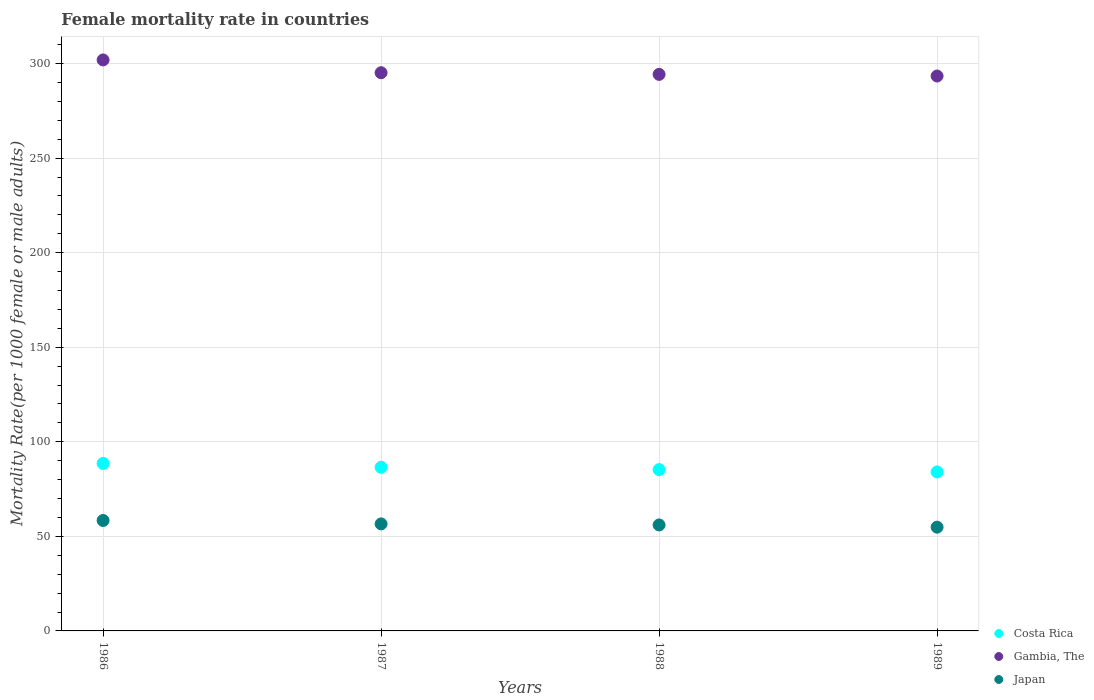What is the female mortality rate in Gambia, The in 1988?
Provide a short and direct response. 294.31. Across all years, what is the maximum female mortality rate in Gambia, The?
Give a very brief answer. 301.94. Across all years, what is the minimum female mortality rate in Japan?
Make the answer very short. 54.87. In which year was the female mortality rate in Costa Rica maximum?
Your answer should be very brief. 1986. In which year was the female mortality rate in Japan minimum?
Offer a terse response. 1989. What is the total female mortality rate in Japan in the graph?
Your answer should be compact. 225.9. What is the difference between the female mortality rate in Japan in 1988 and that in 1989?
Your answer should be very brief. 1.17. What is the difference between the female mortality rate in Costa Rica in 1988 and the female mortality rate in Japan in 1987?
Your answer should be compact. 28.69. What is the average female mortality rate in Gambia, The per year?
Provide a succinct answer. 296.22. In the year 1989, what is the difference between the female mortality rate in Costa Rica and female mortality rate in Gambia, The?
Offer a very short reply. -209.36. What is the ratio of the female mortality rate in Gambia, The in 1986 to that in 1987?
Provide a succinct answer. 1.02. Is the female mortality rate in Gambia, The in 1987 less than that in 1988?
Give a very brief answer. No. What is the difference between the highest and the second highest female mortality rate in Gambia, The?
Your response must be concise. 6.76. What is the difference between the highest and the lowest female mortality rate in Japan?
Provide a succinct answer. 3.53. Does the female mortality rate in Costa Rica monotonically increase over the years?
Provide a short and direct response. No. Does the graph contain grids?
Your answer should be compact. Yes. How many legend labels are there?
Offer a terse response. 3. How are the legend labels stacked?
Offer a very short reply. Vertical. What is the title of the graph?
Your answer should be compact. Female mortality rate in countries. What is the label or title of the X-axis?
Provide a short and direct response. Years. What is the label or title of the Y-axis?
Provide a short and direct response. Mortality Rate(per 1000 female or male adults). What is the Mortality Rate(per 1000 female or male adults) in Costa Rica in 1986?
Provide a succinct answer. 88.56. What is the Mortality Rate(per 1000 female or male adults) in Gambia, The in 1986?
Your answer should be compact. 301.94. What is the Mortality Rate(per 1000 female or male adults) in Japan in 1986?
Ensure brevity in your answer.  58.4. What is the Mortality Rate(per 1000 female or male adults) in Costa Rica in 1987?
Offer a very short reply. 86.5. What is the Mortality Rate(per 1000 female or male adults) in Gambia, The in 1987?
Provide a succinct answer. 295.18. What is the Mortality Rate(per 1000 female or male adults) of Japan in 1987?
Offer a terse response. 56.6. What is the Mortality Rate(per 1000 female or male adults) of Costa Rica in 1988?
Provide a short and direct response. 85.29. What is the Mortality Rate(per 1000 female or male adults) of Gambia, The in 1988?
Ensure brevity in your answer.  294.31. What is the Mortality Rate(per 1000 female or male adults) of Japan in 1988?
Your answer should be very brief. 56.04. What is the Mortality Rate(per 1000 female or male adults) in Costa Rica in 1989?
Offer a terse response. 84.08. What is the Mortality Rate(per 1000 female or male adults) of Gambia, The in 1989?
Offer a very short reply. 293.44. What is the Mortality Rate(per 1000 female or male adults) of Japan in 1989?
Give a very brief answer. 54.87. Across all years, what is the maximum Mortality Rate(per 1000 female or male adults) in Costa Rica?
Ensure brevity in your answer.  88.56. Across all years, what is the maximum Mortality Rate(per 1000 female or male adults) in Gambia, The?
Ensure brevity in your answer.  301.94. Across all years, what is the maximum Mortality Rate(per 1000 female or male adults) in Japan?
Make the answer very short. 58.4. Across all years, what is the minimum Mortality Rate(per 1000 female or male adults) of Costa Rica?
Your response must be concise. 84.08. Across all years, what is the minimum Mortality Rate(per 1000 female or male adults) in Gambia, The?
Your answer should be very brief. 293.44. Across all years, what is the minimum Mortality Rate(per 1000 female or male adults) of Japan?
Your answer should be compact. 54.87. What is the total Mortality Rate(per 1000 female or male adults) in Costa Rica in the graph?
Offer a terse response. 344.44. What is the total Mortality Rate(per 1000 female or male adults) of Gambia, The in the graph?
Ensure brevity in your answer.  1184.87. What is the total Mortality Rate(per 1000 female or male adults) in Japan in the graph?
Your answer should be very brief. 225.9. What is the difference between the Mortality Rate(per 1000 female or male adults) in Costa Rica in 1986 and that in 1987?
Keep it short and to the point. 2.06. What is the difference between the Mortality Rate(per 1000 female or male adults) of Gambia, The in 1986 and that in 1987?
Keep it short and to the point. 6.76. What is the difference between the Mortality Rate(per 1000 female or male adults) of Costa Rica in 1986 and that in 1988?
Provide a succinct answer. 3.27. What is the difference between the Mortality Rate(per 1000 female or male adults) in Gambia, The in 1986 and that in 1988?
Provide a short and direct response. 7.64. What is the difference between the Mortality Rate(per 1000 female or male adults) in Japan in 1986 and that in 1988?
Provide a short and direct response. 2.36. What is the difference between the Mortality Rate(per 1000 female or male adults) of Costa Rica in 1986 and that in 1989?
Your answer should be very brief. 4.49. What is the difference between the Mortality Rate(per 1000 female or male adults) in Gambia, The in 1986 and that in 1989?
Keep it short and to the point. 8.51. What is the difference between the Mortality Rate(per 1000 female or male adults) of Japan in 1986 and that in 1989?
Make the answer very short. 3.53. What is the difference between the Mortality Rate(per 1000 female or male adults) in Costa Rica in 1987 and that in 1988?
Give a very brief answer. 1.21. What is the difference between the Mortality Rate(per 1000 female or male adults) of Gambia, The in 1987 and that in 1988?
Provide a succinct answer. 0.87. What is the difference between the Mortality Rate(per 1000 female or male adults) in Japan in 1987 and that in 1988?
Provide a succinct answer. 0.56. What is the difference between the Mortality Rate(per 1000 female or male adults) in Costa Rica in 1987 and that in 1989?
Keep it short and to the point. 2.42. What is the difference between the Mortality Rate(per 1000 female or male adults) in Gambia, The in 1987 and that in 1989?
Give a very brief answer. 1.74. What is the difference between the Mortality Rate(per 1000 female or male adults) of Japan in 1987 and that in 1989?
Give a very brief answer. 1.73. What is the difference between the Mortality Rate(per 1000 female or male adults) of Costa Rica in 1988 and that in 1989?
Provide a short and direct response. 1.21. What is the difference between the Mortality Rate(per 1000 female or male adults) in Gambia, The in 1988 and that in 1989?
Provide a short and direct response. 0.87. What is the difference between the Mortality Rate(per 1000 female or male adults) of Japan in 1988 and that in 1989?
Offer a very short reply. 1.17. What is the difference between the Mortality Rate(per 1000 female or male adults) in Costa Rica in 1986 and the Mortality Rate(per 1000 female or male adults) in Gambia, The in 1987?
Your response must be concise. -206.61. What is the difference between the Mortality Rate(per 1000 female or male adults) of Costa Rica in 1986 and the Mortality Rate(per 1000 female or male adults) of Japan in 1987?
Make the answer very short. 31.97. What is the difference between the Mortality Rate(per 1000 female or male adults) of Gambia, The in 1986 and the Mortality Rate(per 1000 female or male adults) of Japan in 1987?
Provide a succinct answer. 245.35. What is the difference between the Mortality Rate(per 1000 female or male adults) in Costa Rica in 1986 and the Mortality Rate(per 1000 female or male adults) in Gambia, The in 1988?
Keep it short and to the point. -205.74. What is the difference between the Mortality Rate(per 1000 female or male adults) in Costa Rica in 1986 and the Mortality Rate(per 1000 female or male adults) in Japan in 1988?
Offer a very short reply. 32.53. What is the difference between the Mortality Rate(per 1000 female or male adults) in Gambia, The in 1986 and the Mortality Rate(per 1000 female or male adults) in Japan in 1988?
Offer a very short reply. 245.9. What is the difference between the Mortality Rate(per 1000 female or male adults) of Costa Rica in 1986 and the Mortality Rate(per 1000 female or male adults) of Gambia, The in 1989?
Your response must be concise. -204.87. What is the difference between the Mortality Rate(per 1000 female or male adults) in Costa Rica in 1986 and the Mortality Rate(per 1000 female or male adults) in Japan in 1989?
Offer a very short reply. 33.7. What is the difference between the Mortality Rate(per 1000 female or male adults) in Gambia, The in 1986 and the Mortality Rate(per 1000 female or male adults) in Japan in 1989?
Your response must be concise. 247.07. What is the difference between the Mortality Rate(per 1000 female or male adults) of Costa Rica in 1987 and the Mortality Rate(per 1000 female or male adults) of Gambia, The in 1988?
Keep it short and to the point. -207.8. What is the difference between the Mortality Rate(per 1000 female or male adults) in Costa Rica in 1987 and the Mortality Rate(per 1000 female or male adults) in Japan in 1988?
Provide a succinct answer. 30.46. What is the difference between the Mortality Rate(per 1000 female or male adults) of Gambia, The in 1987 and the Mortality Rate(per 1000 female or male adults) of Japan in 1988?
Make the answer very short. 239.14. What is the difference between the Mortality Rate(per 1000 female or male adults) in Costa Rica in 1987 and the Mortality Rate(per 1000 female or male adults) in Gambia, The in 1989?
Make the answer very short. -206.93. What is the difference between the Mortality Rate(per 1000 female or male adults) of Costa Rica in 1987 and the Mortality Rate(per 1000 female or male adults) of Japan in 1989?
Your answer should be very brief. 31.64. What is the difference between the Mortality Rate(per 1000 female or male adults) of Gambia, The in 1987 and the Mortality Rate(per 1000 female or male adults) of Japan in 1989?
Offer a terse response. 240.31. What is the difference between the Mortality Rate(per 1000 female or male adults) of Costa Rica in 1988 and the Mortality Rate(per 1000 female or male adults) of Gambia, The in 1989?
Provide a short and direct response. -208.15. What is the difference between the Mortality Rate(per 1000 female or male adults) in Costa Rica in 1988 and the Mortality Rate(per 1000 female or male adults) in Japan in 1989?
Offer a very short reply. 30.42. What is the difference between the Mortality Rate(per 1000 female or male adults) in Gambia, The in 1988 and the Mortality Rate(per 1000 female or male adults) in Japan in 1989?
Your answer should be very brief. 239.44. What is the average Mortality Rate(per 1000 female or male adults) of Costa Rica per year?
Offer a very short reply. 86.11. What is the average Mortality Rate(per 1000 female or male adults) in Gambia, The per year?
Offer a terse response. 296.22. What is the average Mortality Rate(per 1000 female or male adults) of Japan per year?
Give a very brief answer. 56.48. In the year 1986, what is the difference between the Mortality Rate(per 1000 female or male adults) of Costa Rica and Mortality Rate(per 1000 female or male adults) of Gambia, The?
Offer a very short reply. -213.38. In the year 1986, what is the difference between the Mortality Rate(per 1000 female or male adults) of Costa Rica and Mortality Rate(per 1000 female or male adults) of Japan?
Offer a terse response. 30.17. In the year 1986, what is the difference between the Mortality Rate(per 1000 female or male adults) in Gambia, The and Mortality Rate(per 1000 female or male adults) in Japan?
Provide a succinct answer. 243.55. In the year 1987, what is the difference between the Mortality Rate(per 1000 female or male adults) in Costa Rica and Mortality Rate(per 1000 female or male adults) in Gambia, The?
Keep it short and to the point. -208.68. In the year 1987, what is the difference between the Mortality Rate(per 1000 female or male adults) in Costa Rica and Mortality Rate(per 1000 female or male adults) in Japan?
Provide a succinct answer. 29.91. In the year 1987, what is the difference between the Mortality Rate(per 1000 female or male adults) in Gambia, The and Mortality Rate(per 1000 female or male adults) in Japan?
Your answer should be compact. 238.58. In the year 1988, what is the difference between the Mortality Rate(per 1000 female or male adults) in Costa Rica and Mortality Rate(per 1000 female or male adults) in Gambia, The?
Give a very brief answer. -209.02. In the year 1988, what is the difference between the Mortality Rate(per 1000 female or male adults) in Costa Rica and Mortality Rate(per 1000 female or male adults) in Japan?
Your response must be concise. 29.25. In the year 1988, what is the difference between the Mortality Rate(per 1000 female or male adults) of Gambia, The and Mortality Rate(per 1000 female or male adults) of Japan?
Offer a terse response. 238.27. In the year 1989, what is the difference between the Mortality Rate(per 1000 female or male adults) of Costa Rica and Mortality Rate(per 1000 female or male adults) of Gambia, The?
Your answer should be compact. -209.36. In the year 1989, what is the difference between the Mortality Rate(per 1000 female or male adults) in Costa Rica and Mortality Rate(per 1000 female or male adults) in Japan?
Keep it short and to the point. 29.21. In the year 1989, what is the difference between the Mortality Rate(per 1000 female or male adults) in Gambia, The and Mortality Rate(per 1000 female or male adults) in Japan?
Offer a terse response. 238.57. What is the ratio of the Mortality Rate(per 1000 female or male adults) of Costa Rica in 1986 to that in 1987?
Make the answer very short. 1.02. What is the ratio of the Mortality Rate(per 1000 female or male adults) of Gambia, The in 1986 to that in 1987?
Give a very brief answer. 1.02. What is the ratio of the Mortality Rate(per 1000 female or male adults) of Japan in 1986 to that in 1987?
Give a very brief answer. 1.03. What is the ratio of the Mortality Rate(per 1000 female or male adults) of Costa Rica in 1986 to that in 1988?
Provide a succinct answer. 1.04. What is the ratio of the Mortality Rate(per 1000 female or male adults) in Gambia, The in 1986 to that in 1988?
Make the answer very short. 1.03. What is the ratio of the Mortality Rate(per 1000 female or male adults) of Japan in 1986 to that in 1988?
Offer a terse response. 1.04. What is the ratio of the Mortality Rate(per 1000 female or male adults) in Costa Rica in 1986 to that in 1989?
Your response must be concise. 1.05. What is the ratio of the Mortality Rate(per 1000 female or male adults) in Japan in 1986 to that in 1989?
Provide a short and direct response. 1.06. What is the ratio of the Mortality Rate(per 1000 female or male adults) in Costa Rica in 1987 to that in 1988?
Give a very brief answer. 1.01. What is the ratio of the Mortality Rate(per 1000 female or male adults) in Gambia, The in 1987 to that in 1988?
Provide a succinct answer. 1. What is the ratio of the Mortality Rate(per 1000 female or male adults) of Japan in 1987 to that in 1988?
Give a very brief answer. 1.01. What is the ratio of the Mortality Rate(per 1000 female or male adults) in Costa Rica in 1987 to that in 1989?
Give a very brief answer. 1.03. What is the ratio of the Mortality Rate(per 1000 female or male adults) of Gambia, The in 1987 to that in 1989?
Offer a terse response. 1.01. What is the ratio of the Mortality Rate(per 1000 female or male adults) in Japan in 1987 to that in 1989?
Give a very brief answer. 1.03. What is the ratio of the Mortality Rate(per 1000 female or male adults) in Costa Rica in 1988 to that in 1989?
Your response must be concise. 1.01. What is the ratio of the Mortality Rate(per 1000 female or male adults) of Japan in 1988 to that in 1989?
Your answer should be very brief. 1.02. What is the difference between the highest and the second highest Mortality Rate(per 1000 female or male adults) of Costa Rica?
Keep it short and to the point. 2.06. What is the difference between the highest and the second highest Mortality Rate(per 1000 female or male adults) of Gambia, The?
Your answer should be compact. 6.76. What is the difference between the highest and the lowest Mortality Rate(per 1000 female or male adults) in Costa Rica?
Provide a short and direct response. 4.49. What is the difference between the highest and the lowest Mortality Rate(per 1000 female or male adults) in Gambia, The?
Your answer should be very brief. 8.51. What is the difference between the highest and the lowest Mortality Rate(per 1000 female or male adults) of Japan?
Ensure brevity in your answer.  3.53. 